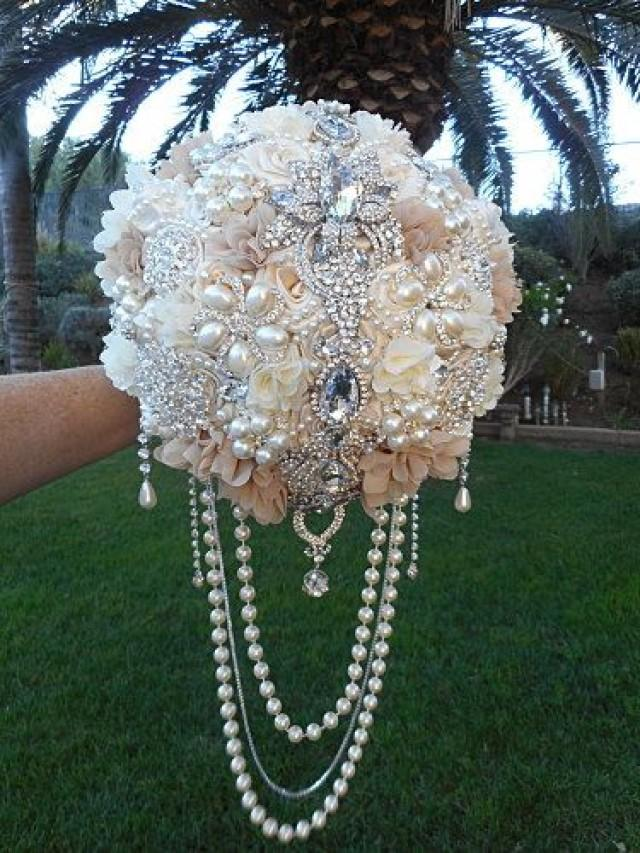Considering the design elements and materials used in the creation of this bouquet, what might be the occasion or event for which this bouquet is intended, and why would this particular style be chosen? This intricately designed bouquet, with its lush array of artificial flowers, pearls, and crystal brooches, is styled for a wedding. The choice of pristine white and cream hues resonates with traditional wedding themes, where such colors symbolize purity and unity. Its embellishments, which include a sophisticated blend of timeless elements with a dash of splendor, make it an ideal accessory for a bride seeking a blend of classic elegance and modern luxury. The use of faux flowers not only ensures the bouquet remains an everlasting keepsake from the special occasion but also offers a practical advantage as it is immune to wilting and can be prepared well in advance, alleviating some of the wedding day stress. 